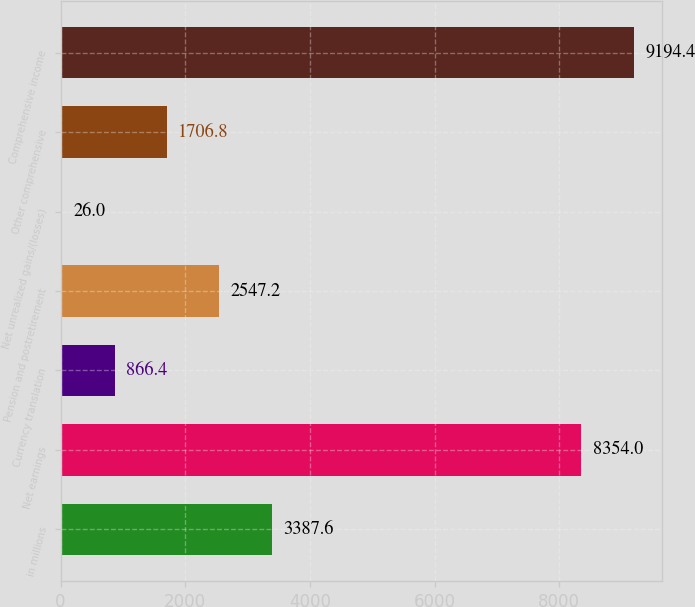<chart> <loc_0><loc_0><loc_500><loc_500><bar_chart><fcel>in millions<fcel>Net earnings<fcel>Currency translation<fcel>Pension and postretirement<fcel>Net unrealized gains/(losses)<fcel>Other comprehensive<fcel>Comprehensive income<nl><fcel>3387.6<fcel>8354<fcel>866.4<fcel>2547.2<fcel>26<fcel>1706.8<fcel>9194.4<nl></chart> 